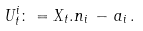Convert formula to latex. <formula><loc_0><loc_0><loc_500><loc_500>U _ { t } ^ { i } \colon = X _ { t } . n _ { i } \, - \, a _ { i } \, .</formula> 